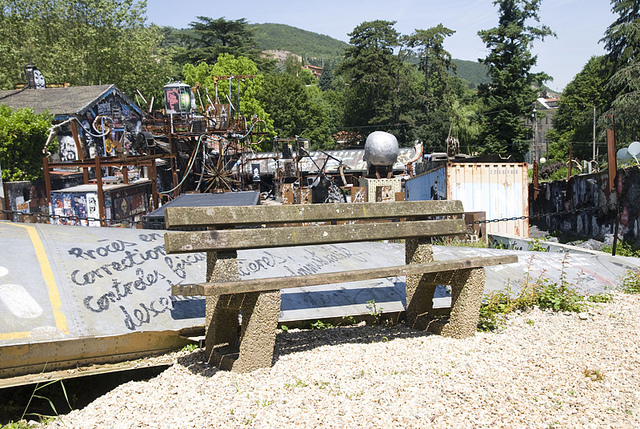Read all the text in this image. Proces Controles correction eres fiscal 